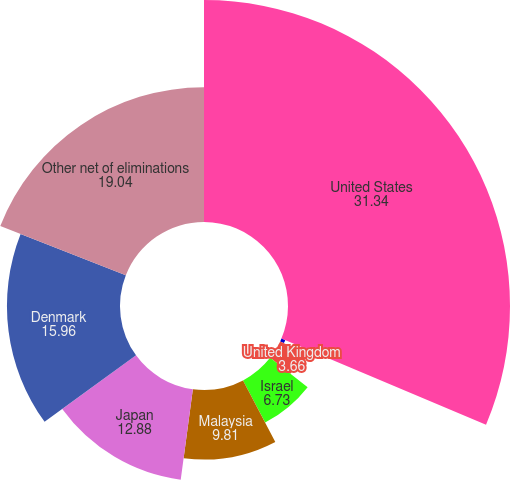Convert chart. <chart><loc_0><loc_0><loc_500><loc_500><pie_chart><fcel>United States<fcel>China<fcel>United Kingdom<fcel>Israel<fcel>Malaysia<fcel>Japan<fcel>Denmark<fcel>Other net of eliminations<nl><fcel>31.34%<fcel>0.58%<fcel>3.66%<fcel>6.73%<fcel>9.81%<fcel>12.88%<fcel>15.96%<fcel>19.04%<nl></chart> 